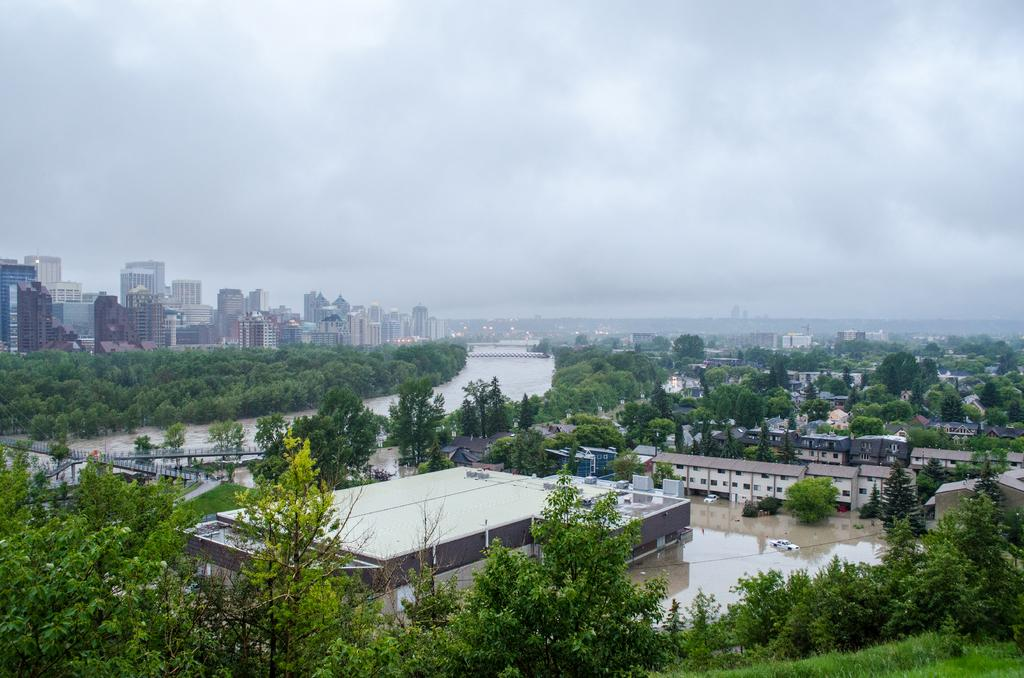What type of natural vegetation can be seen in the image? There are trees in the image. What type of man-made structures are visible in the image? There are buildings in the image. What is the body of water in the image used for? The water is being used by vehicles in the image. What is visible in the background of the image? The sky is visible in the background of the image. What other objects can be seen in the image besides trees, buildings, and vehicles? There are other objects present in the image. What type of milk is being poured into the dress in the image? There is no milk or dress present in the image. How many objects are there in the image? It is not possible to determine the exact number of objects in the image from the provided facts. 